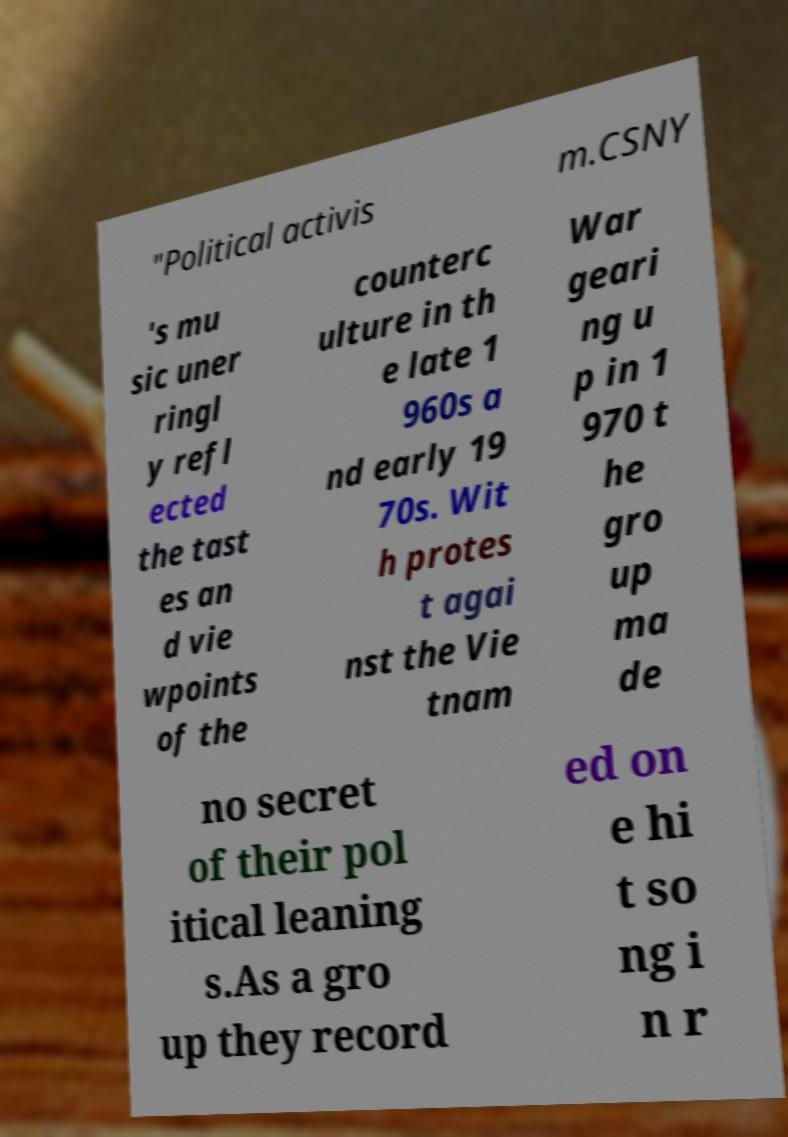There's text embedded in this image that I need extracted. Can you transcribe it verbatim? "Political activis m.CSNY 's mu sic uner ringl y refl ected the tast es an d vie wpoints of the counterc ulture in th e late 1 960s a nd early 19 70s. Wit h protes t agai nst the Vie tnam War geari ng u p in 1 970 t he gro up ma de no secret of their pol itical leaning s.As a gro up they record ed on e hi t so ng i n r 